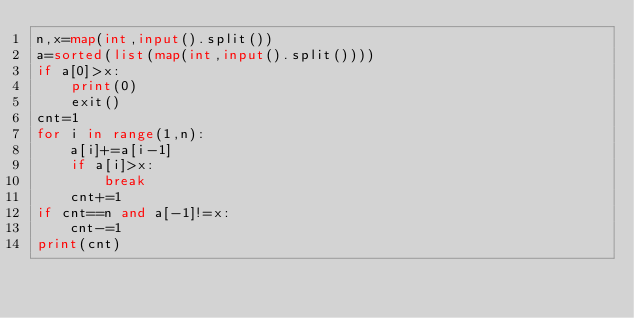Convert code to text. <code><loc_0><loc_0><loc_500><loc_500><_Python_>n,x=map(int,input().split())
a=sorted(list(map(int,input().split())))
if a[0]>x:
    print(0)
    exit()
cnt=1
for i in range(1,n):
    a[i]+=a[i-1]
    if a[i]>x:
        break
    cnt+=1
if cnt==n and a[-1]!=x:
    cnt-=1
print(cnt)</code> 